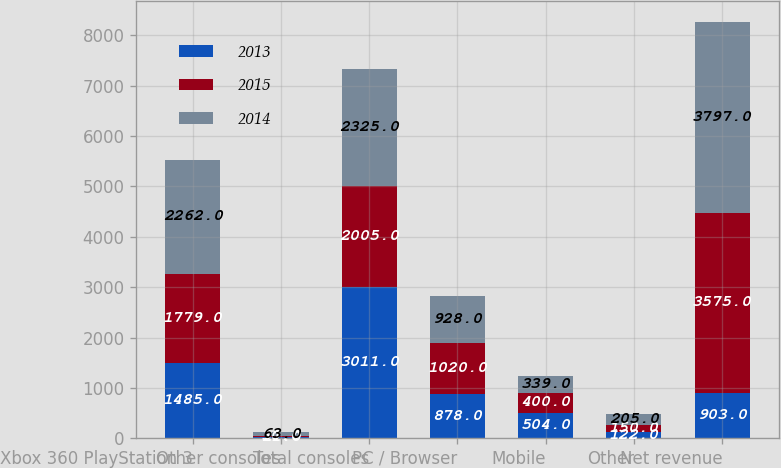Convert chart to OTSL. <chart><loc_0><loc_0><loc_500><loc_500><stacked_bar_chart><ecel><fcel>Xbox 360 PlayStation 3<fcel>Other consoles<fcel>Total consoles<fcel>PC / Browser<fcel>Mobile<fcel>Other<fcel>Net revenue<nl><fcel>2013<fcel>1485<fcel>21<fcel>3011<fcel>878<fcel>504<fcel>122<fcel>903<nl><fcel>2015<fcel>1779<fcel>30<fcel>2005<fcel>1020<fcel>400<fcel>150<fcel>3575<nl><fcel>2014<fcel>2262<fcel>63<fcel>2325<fcel>928<fcel>339<fcel>205<fcel>3797<nl></chart> 